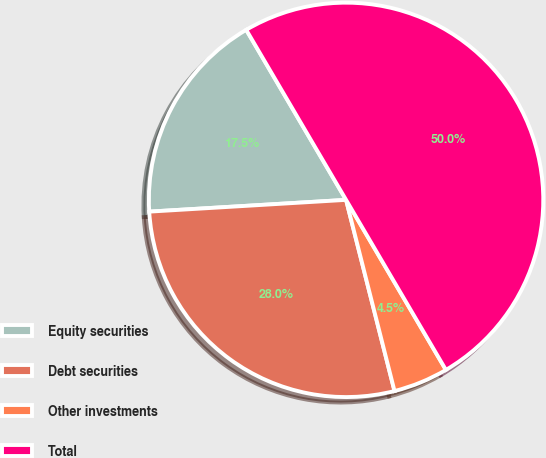Convert chart. <chart><loc_0><loc_0><loc_500><loc_500><pie_chart><fcel>Equity securities<fcel>Debt securities<fcel>Other investments<fcel>Total<nl><fcel>17.5%<fcel>28.0%<fcel>4.5%<fcel>50.0%<nl></chart> 